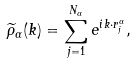Convert formula to latex. <formula><loc_0><loc_0><loc_500><loc_500>\widetilde { \rho } _ { \alpha } ( k ) = \sum _ { j = 1 } ^ { N _ { \alpha } } e ^ { i k \cdot r _ { j } ^ { \alpha } } ,</formula> 